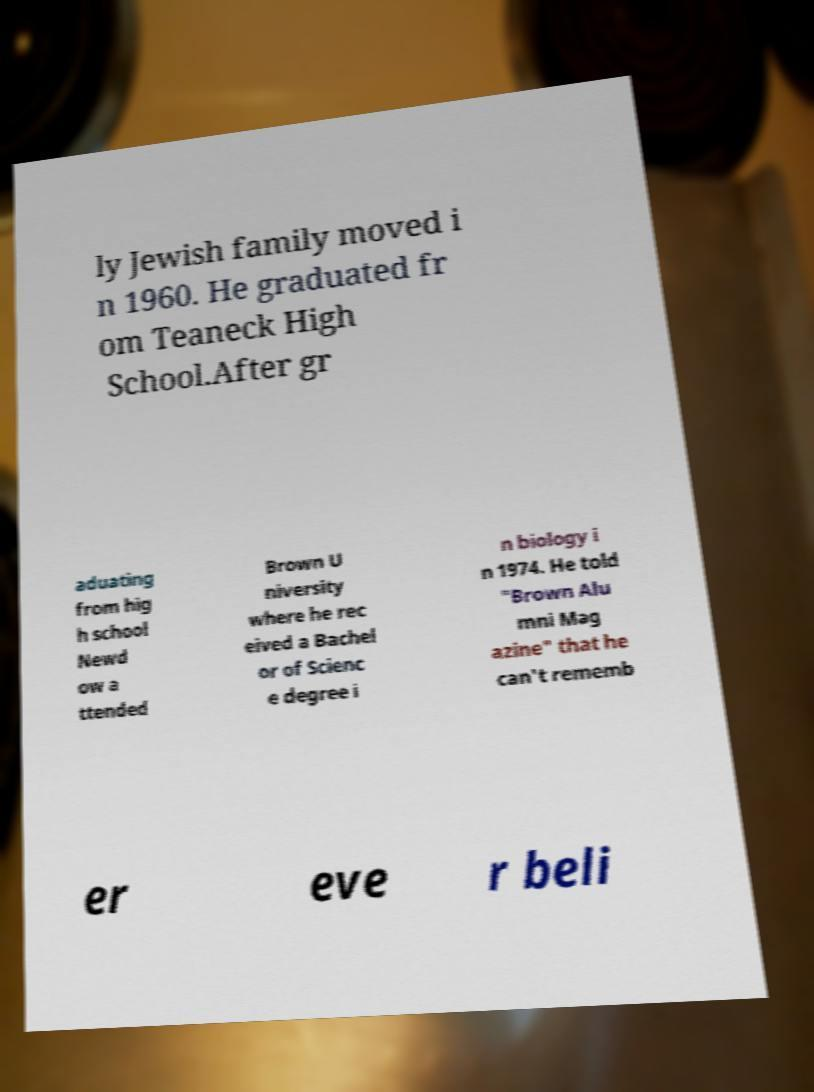Please identify and transcribe the text found in this image. ly Jewish family moved i n 1960. He graduated fr om Teaneck High School.After gr aduating from hig h school Newd ow a ttended Brown U niversity where he rec eived a Bachel or of Scienc e degree i n biology i n 1974. He told "Brown Alu mni Mag azine" that he can't rememb er eve r beli 